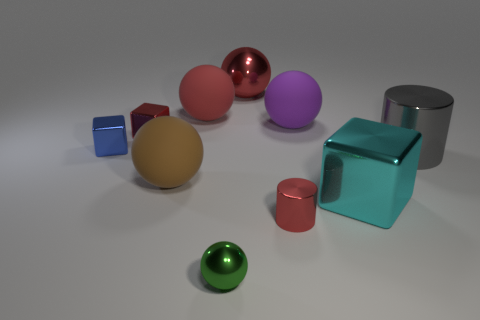How many small red cylinders are the same material as the large cylinder? After examining the image, it appears that there is only one small red cylinder that shares the same glossy metallic appearance as the large cylinder. 